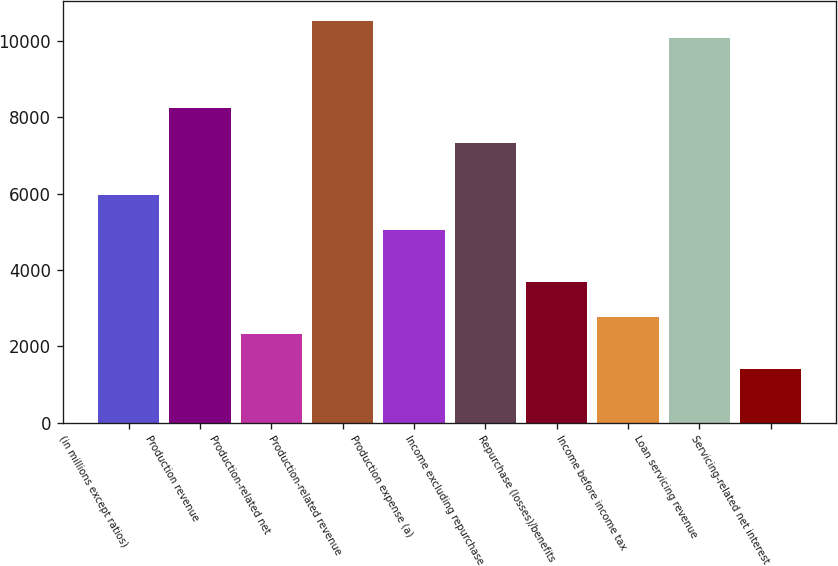Convert chart. <chart><loc_0><loc_0><loc_500><loc_500><bar_chart><fcel>(in millions except ratios)<fcel>Production revenue<fcel>Production-related net<fcel>Production-related revenue<fcel>Production expense (a)<fcel>Income excluding repurchase<fcel>Repurchase (losses)/benefits<fcel>Income before income tax<fcel>Loan servicing revenue<fcel>Servicing-related net interest<nl><fcel>5959.7<fcel>8239.2<fcel>2312.5<fcel>10518.7<fcel>5047.9<fcel>7327.4<fcel>3680.2<fcel>2768.4<fcel>10062.8<fcel>1400.7<nl></chart> 